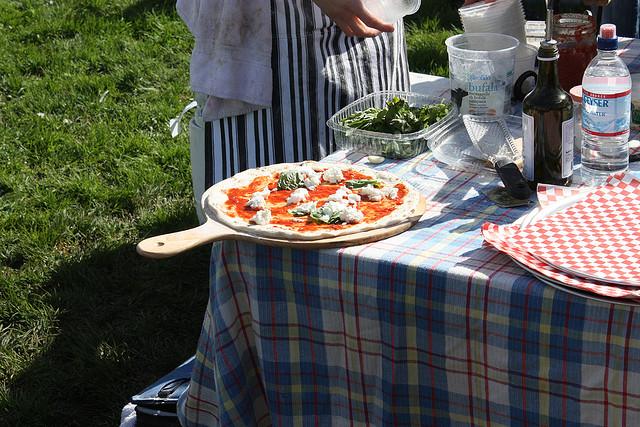Is there a cheese grater in this picture?
Give a very brief answer. Yes. Is the person wearing an apron?
Give a very brief answer. Yes. What kind of pizza is this?
Answer briefly. Veggie. 